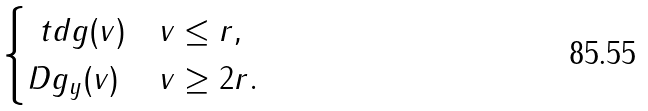Convert formula to latex. <formula><loc_0><loc_0><loc_500><loc_500>\begin{cases} \ t d g ( v ) & \| v \| \leq r , \\ D g _ { y } ( v ) & \| v \| \geq 2 r . \end{cases}</formula> 